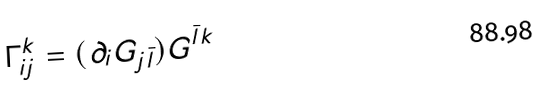<formula> <loc_0><loc_0><loc_500><loc_500>\Gamma _ { i j } ^ { k } = ( \partial _ { i } G _ { j \bar { l } } ) G ^ { \bar { l } k }</formula> 